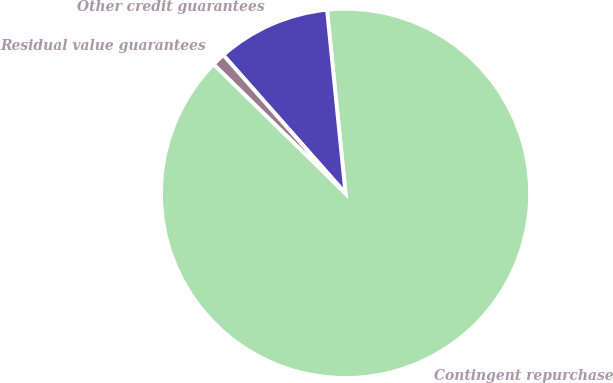Convert chart. <chart><loc_0><loc_0><loc_500><loc_500><pie_chart><fcel>Contingent repurchase<fcel>Other credit guarantees<fcel>Residual value guarantees<nl><fcel>88.93%<fcel>9.92%<fcel>1.15%<nl></chart> 